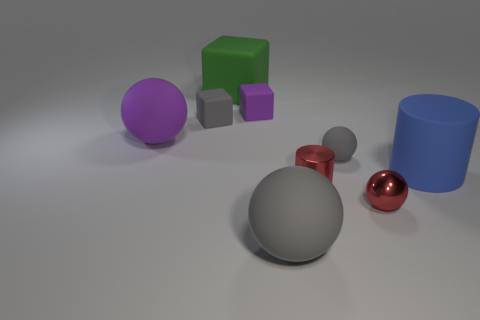Can you describe the colors and materials of the objects in the image? Certainly! The image displays objects with various colors and materials. There's a large gray sphere with a rubber-like texture, a purple matte sphere, and a green cube with a similar matte appearance. To the right, there's a cylindrical shape with a blue matte finish. In the foreground, there are two smaller objects, a red sphere and a tiny gray cube, both with a shiny, possibly metallic finish. 